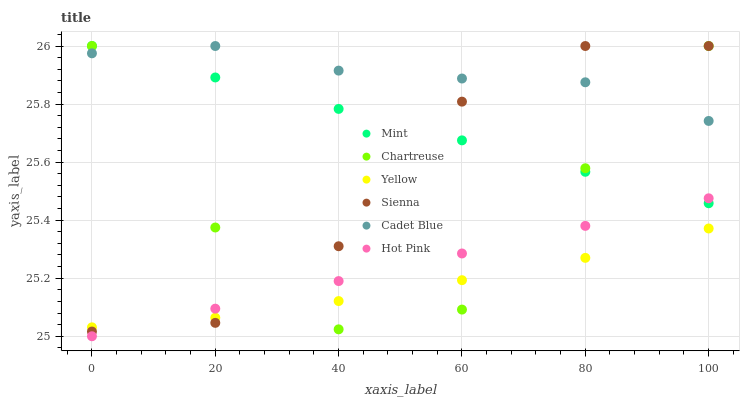Does Yellow have the minimum area under the curve?
Answer yes or no. Yes. Does Cadet Blue have the maximum area under the curve?
Answer yes or no. Yes. Does Hot Pink have the minimum area under the curve?
Answer yes or no. No. Does Hot Pink have the maximum area under the curve?
Answer yes or no. No. Is Hot Pink the smoothest?
Answer yes or no. Yes. Is Chartreuse the roughest?
Answer yes or no. Yes. Is Yellow the smoothest?
Answer yes or no. No. Is Yellow the roughest?
Answer yes or no. No. Does Hot Pink have the lowest value?
Answer yes or no. Yes. Does Yellow have the lowest value?
Answer yes or no. No. Does Mint have the highest value?
Answer yes or no. Yes. Does Hot Pink have the highest value?
Answer yes or no. No. Is Yellow less than Mint?
Answer yes or no. Yes. Is Cadet Blue greater than Yellow?
Answer yes or no. Yes. Does Chartreuse intersect Mint?
Answer yes or no. Yes. Is Chartreuse less than Mint?
Answer yes or no. No. Is Chartreuse greater than Mint?
Answer yes or no. No. Does Yellow intersect Mint?
Answer yes or no. No. 